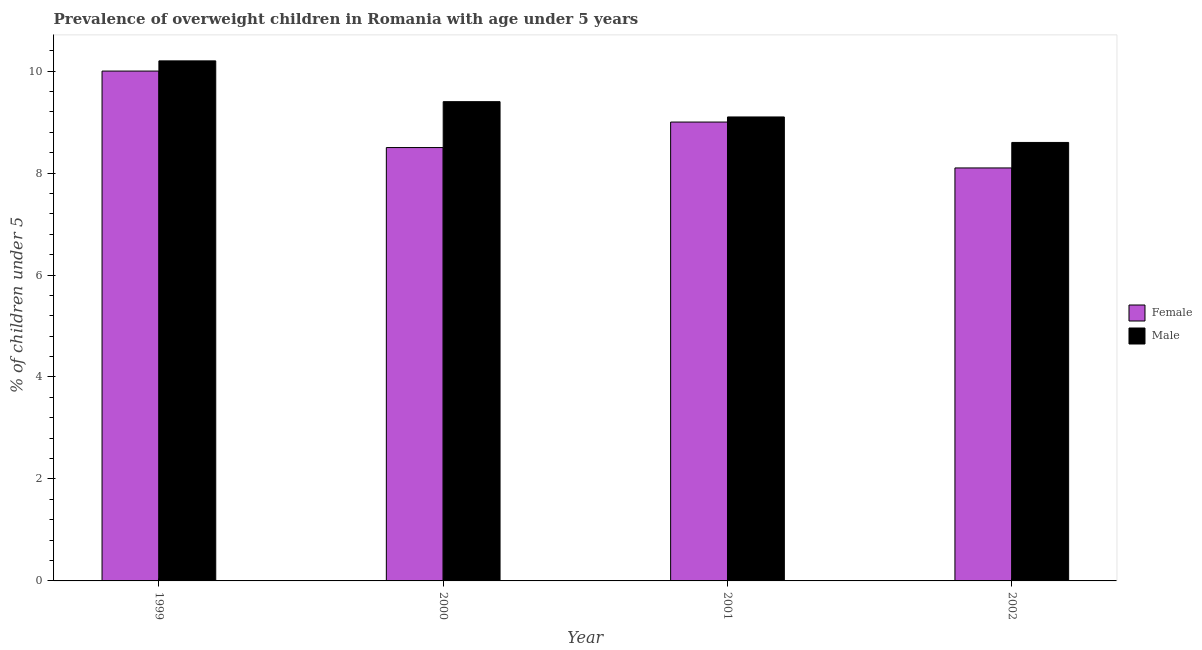How many different coloured bars are there?
Give a very brief answer. 2. How many groups of bars are there?
Ensure brevity in your answer.  4. Are the number of bars per tick equal to the number of legend labels?
Provide a succinct answer. Yes. Are the number of bars on each tick of the X-axis equal?
Make the answer very short. Yes. How many bars are there on the 3rd tick from the left?
Your answer should be compact. 2. What is the label of the 1st group of bars from the left?
Keep it short and to the point. 1999. What is the percentage of obese male children in 2000?
Offer a terse response. 9.4. Across all years, what is the maximum percentage of obese female children?
Offer a very short reply. 10. Across all years, what is the minimum percentage of obese female children?
Provide a short and direct response. 8.1. What is the total percentage of obese female children in the graph?
Provide a short and direct response. 35.6. What is the difference between the percentage of obese female children in 2001 and the percentage of obese male children in 2000?
Provide a succinct answer. 0.5. What is the average percentage of obese male children per year?
Offer a terse response. 9.33. What is the ratio of the percentage of obese female children in 2001 to that in 2002?
Provide a succinct answer. 1.11. Is the difference between the percentage of obese male children in 2001 and 2002 greater than the difference between the percentage of obese female children in 2001 and 2002?
Your answer should be very brief. No. What is the difference between the highest and the second highest percentage of obese male children?
Your response must be concise. 0.8. What is the difference between the highest and the lowest percentage of obese male children?
Provide a succinct answer. 1.6. What does the 1st bar from the left in 2000 represents?
Offer a terse response. Female. How many bars are there?
Offer a terse response. 8. Are all the bars in the graph horizontal?
Your answer should be compact. No. Are the values on the major ticks of Y-axis written in scientific E-notation?
Your response must be concise. No. Does the graph contain grids?
Offer a terse response. No. How many legend labels are there?
Make the answer very short. 2. What is the title of the graph?
Keep it short and to the point. Prevalence of overweight children in Romania with age under 5 years. Does "DAC donors" appear as one of the legend labels in the graph?
Ensure brevity in your answer.  No. What is the label or title of the Y-axis?
Offer a terse response.  % of children under 5. What is the  % of children under 5 of Female in 1999?
Your response must be concise. 10. What is the  % of children under 5 in Male in 1999?
Give a very brief answer. 10.2. What is the  % of children under 5 in Female in 2000?
Offer a very short reply. 8.5. What is the  % of children under 5 of Male in 2000?
Offer a very short reply. 9.4. What is the  % of children under 5 of Female in 2001?
Offer a very short reply. 9. What is the  % of children under 5 in Male in 2001?
Make the answer very short. 9.1. What is the  % of children under 5 in Female in 2002?
Offer a very short reply. 8.1. What is the  % of children under 5 of Male in 2002?
Your answer should be very brief. 8.6. Across all years, what is the maximum  % of children under 5 of Female?
Keep it short and to the point. 10. Across all years, what is the maximum  % of children under 5 in Male?
Provide a succinct answer. 10.2. Across all years, what is the minimum  % of children under 5 of Female?
Ensure brevity in your answer.  8.1. Across all years, what is the minimum  % of children under 5 of Male?
Your answer should be very brief. 8.6. What is the total  % of children under 5 in Female in the graph?
Your response must be concise. 35.6. What is the total  % of children under 5 of Male in the graph?
Offer a terse response. 37.3. What is the difference between the  % of children under 5 in Male in 1999 and that in 2000?
Your answer should be compact. 0.8. What is the difference between the  % of children under 5 of Female in 1999 and that in 2001?
Your answer should be compact. 1. What is the difference between the  % of children under 5 in Male in 1999 and that in 2002?
Keep it short and to the point. 1.6. What is the difference between the  % of children under 5 in Female in 2000 and that in 2001?
Your response must be concise. -0.5. What is the difference between the  % of children under 5 of Male in 2000 and that in 2001?
Ensure brevity in your answer.  0.3. What is the difference between the  % of children under 5 in Female in 2000 and that in 2002?
Your answer should be compact. 0.4. What is the difference between the  % of children under 5 of Male in 2000 and that in 2002?
Provide a succinct answer. 0.8. What is the difference between the  % of children under 5 of Female in 2001 and that in 2002?
Offer a very short reply. 0.9. What is the difference between the  % of children under 5 in Female in 1999 and the  % of children under 5 in Male in 2001?
Provide a succinct answer. 0.9. What is the difference between the  % of children under 5 of Female in 1999 and the  % of children under 5 of Male in 2002?
Ensure brevity in your answer.  1.4. What is the average  % of children under 5 in Female per year?
Your answer should be compact. 8.9. What is the average  % of children under 5 in Male per year?
Give a very brief answer. 9.32. In the year 1999, what is the difference between the  % of children under 5 in Female and  % of children under 5 in Male?
Provide a succinct answer. -0.2. What is the ratio of the  % of children under 5 in Female in 1999 to that in 2000?
Keep it short and to the point. 1.18. What is the ratio of the  % of children under 5 in Male in 1999 to that in 2000?
Your answer should be very brief. 1.09. What is the ratio of the  % of children under 5 in Female in 1999 to that in 2001?
Offer a terse response. 1.11. What is the ratio of the  % of children under 5 in Male in 1999 to that in 2001?
Ensure brevity in your answer.  1.12. What is the ratio of the  % of children under 5 in Female in 1999 to that in 2002?
Give a very brief answer. 1.23. What is the ratio of the  % of children under 5 of Male in 1999 to that in 2002?
Provide a succinct answer. 1.19. What is the ratio of the  % of children under 5 of Male in 2000 to that in 2001?
Ensure brevity in your answer.  1.03. What is the ratio of the  % of children under 5 of Female in 2000 to that in 2002?
Make the answer very short. 1.05. What is the ratio of the  % of children under 5 in Male in 2000 to that in 2002?
Offer a terse response. 1.09. What is the ratio of the  % of children under 5 of Male in 2001 to that in 2002?
Your answer should be compact. 1.06. What is the difference between the highest and the second highest  % of children under 5 in Male?
Give a very brief answer. 0.8. What is the difference between the highest and the lowest  % of children under 5 in Female?
Offer a very short reply. 1.9. 